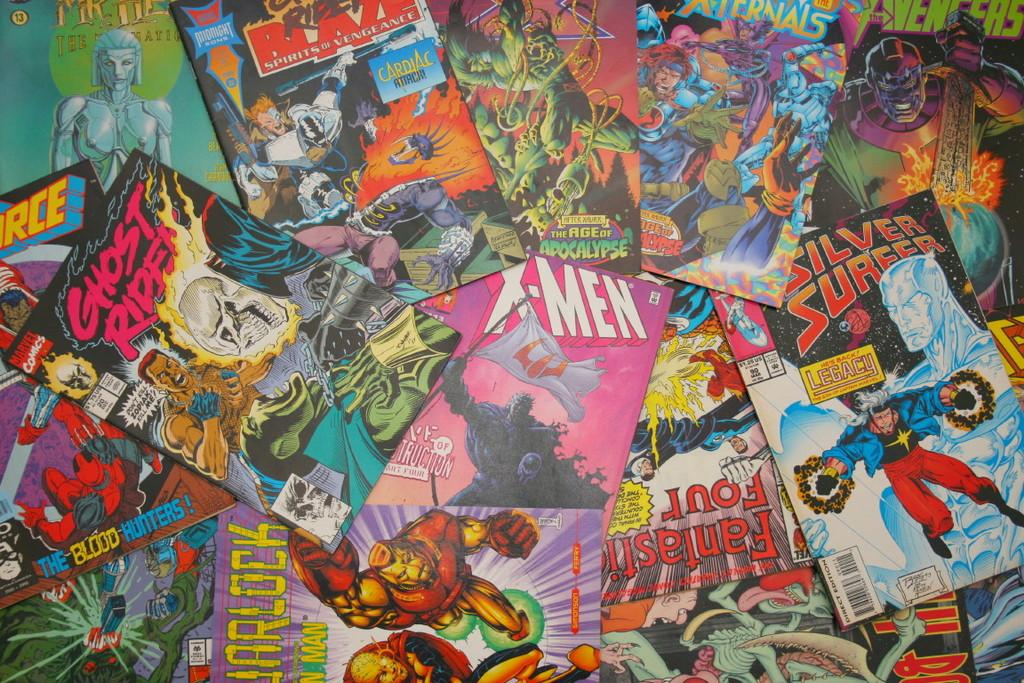<image>
Give a short and clear explanation of the subsequent image. the x men comic is in the middle of the mess 